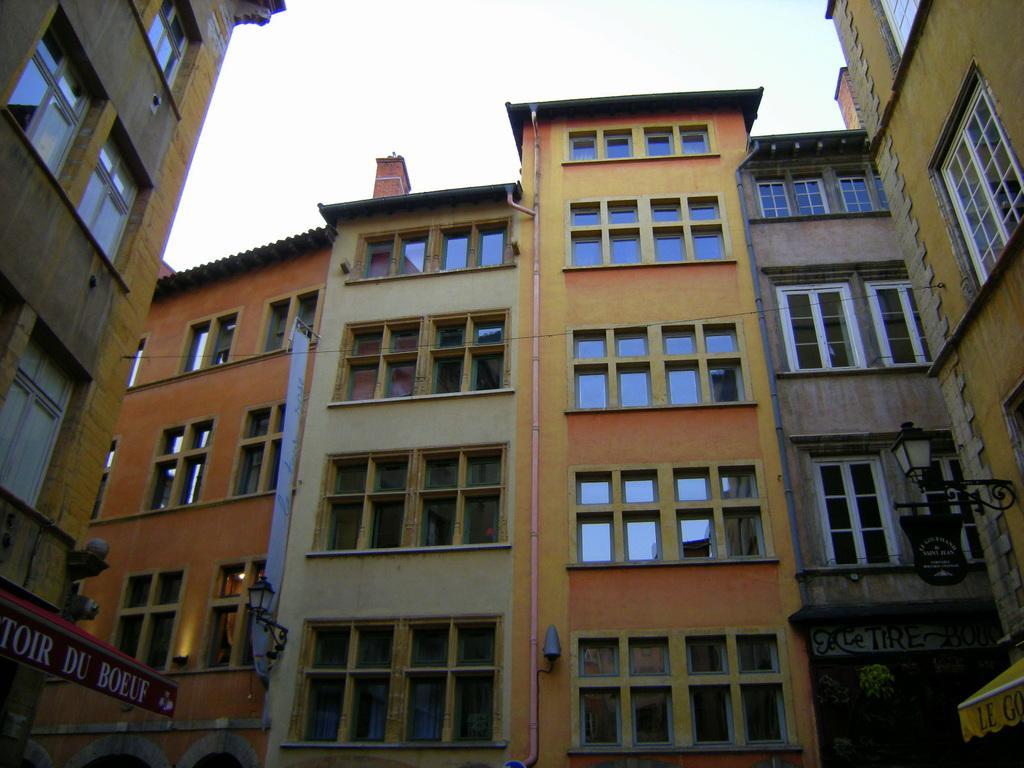Could you give a brief overview of what you see in this image? In this picture we can see some text on the boards. There is some text visible on a yellow object on the right side. We can see a few lanterns, rods, glass objects, windows and other objects are visible on the buildings. There is the sky visible on top of the picture. 